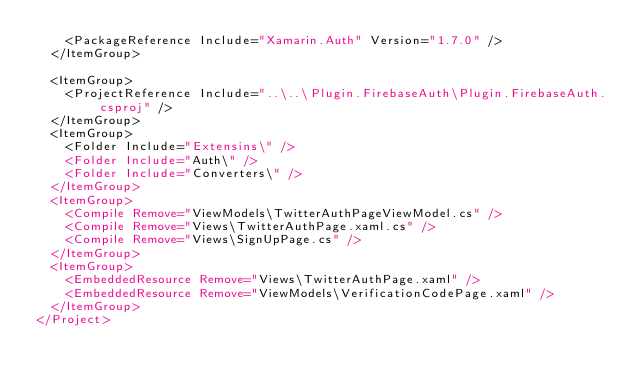Convert code to text. <code><loc_0><loc_0><loc_500><loc_500><_XML_>    <PackageReference Include="Xamarin.Auth" Version="1.7.0" />
  </ItemGroup>

  <ItemGroup>
    <ProjectReference Include="..\..\Plugin.FirebaseAuth\Plugin.FirebaseAuth.csproj" />
  </ItemGroup>
  <ItemGroup>
    <Folder Include="Extensins\" />
    <Folder Include="Auth\" />
    <Folder Include="Converters\" />
  </ItemGroup>
  <ItemGroup>
    <Compile Remove="ViewModels\TwitterAuthPageViewModel.cs" />
    <Compile Remove="Views\TwitterAuthPage.xaml.cs" />
    <Compile Remove="Views\SignUpPage.cs" />
  </ItemGroup>
  <ItemGroup>
    <EmbeddedResource Remove="Views\TwitterAuthPage.xaml" />
    <EmbeddedResource Remove="ViewModels\VerificationCodePage.xaml" />
  </ItemGroup>
</Project></code> 